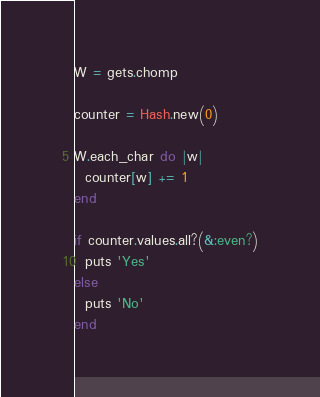Convert code to text. <code><loc_0><loc_0><loc_500><loc_500><_Ruby_>W = gets.chomp

counter = Hash.new(0)

W.each_char do |w|
  counter[w] += 1
end

if counter.values.all?(&:even?)
  puts 'Yes'
else
  puts 'No'
end
</code> 